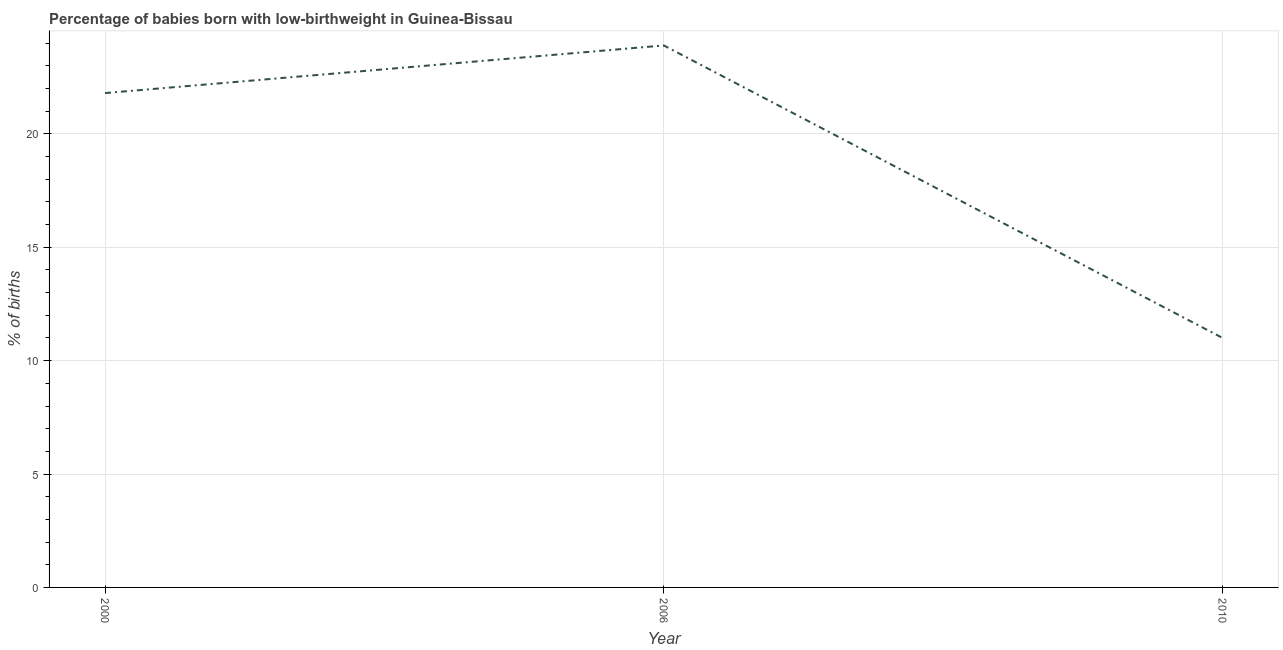What is the percentage of babies who were born with low-birthweight in 2006?
Provide a succinct answer. 23.9. Across all years, what is the maximum percentage of babies who were born with low-birthweight?
Offer a very short reply. 23.9. In which year was the percentage of babies who were born with low-birthweight maximum?
Your answer should be very brief. 2006. In which year was the percentage of babies who were born with low-birthweight minimum?
Offer a terse response. 2010. What is the sum of the percentage of babies who were born with low-birthweight?
Your response must be concise. 56.7. What is the difference between the percentage of babies who were born with low-birthweight in 2000 and 2006?
Provide a short and direct response. -2.1. What is the average percentage of babies who were born with low-birthweight per year?
Keep it short and to the point. 18.9. What is the median percentage of babies who were born with low-birthweight?
Offer a terse response. 21.8. What is the ratio of the percentage of babies who were born with low-birthweight in 2000 to that in 2010?
Give a very brief answer. 1.98. Is the percentage of babies who were born with low-birthweight in 2000 less than that in 2006?
Make the answer very short. Yes. What is the difference between the highest and the second highest percentage of babies who were born with low-birthweight?
Offer a very short reply. 2.1. What is the difference between the highest and the lowest percentage of babies who were born with low-birthweight?
Keep it short and to the point. 12.9. How many lines are there?
Ensure brevity in your answer.  1. How many years are there in the graph?
Offer a terse response. 3. Are the values on the major ticks of Y-axis written in scientific E-notation?
Provide a succinct answer. No. Does the graph contain any zero values?
Your answer should be compact. No. Does the graph contain grids?
Your answer should be compact. Yes. What is the title of the graph?
Your answer should be very brief. Percentage of babies born with low-birthweight in Guinea-Bissau. What is the label or title of the Y-axis?
Provide a succinct answer. % of births. What is the % of births of 2000?
Your response must be concise. 21.8. What is the % of births in 2006?
Give a very brief answer. 23.9. What is the % of births in 2010?
Your answer should be very brief. 11. What is the difference between the % of births in 2000 and 2006?
Offer a terse response. -2.1. What is the difference between the % of births in 2000 and 2010?
Your answer should be compact. 10.8. What is the ratio of the % of births in 2000 to that in 2006?
Your response must be concise. 0.91. What is the ratio of the % of births in 2000 to that in 2010?
Ensure brevity in your answer.  1.98. What is the ratio of the % of births in 2006 to that in 2010?
Offer a terse response. 2.17. 